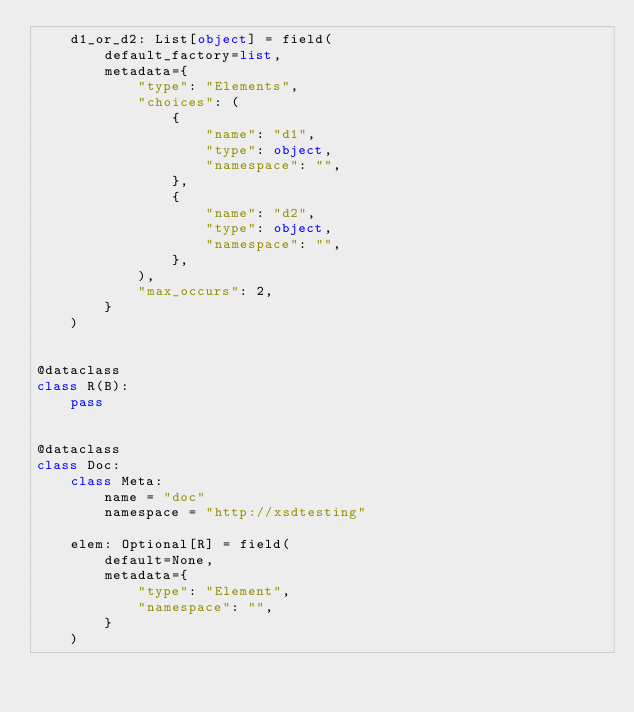Convert code to text. <code><loc_0><loc_0><loc_500><loc_500><_Python_>    d1_or_d2: List[object] = field(
        default_factory=list,
        metadata={
            "type": "Elements",
            "choices": (
                {
                    "name": "d1",
                    "type": object,
                    "namespace": "",
                },
                {
                    "name": "d2",
                    "type": object,
                    "namespace": "",
                },
            ),
            "max_occurs": 2,
        }
    )


@dataclass
class R(B):
    pass


@dataclass
class Doc:
    class Meta:
        name = "doc"
        namespace = "http://xsdtesting"

    elem: Optional[R] = field(
        default=None,
        metadata={
            "type": "Element",
            "namespace": "",
        }
    )
</code> 